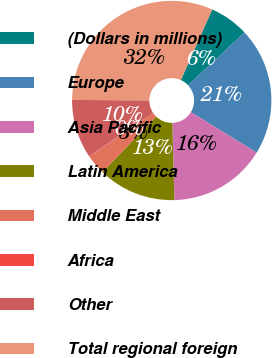Convert chart to OTSL. <chart><loc_0><loc_0><loc_500><loc_500><pie_chart><fcel>(Dollars in millions)<fcel>Europe<fcel>Asia Pacific<fcel>Latin America<fcel>Middle East<fcel>Africa<fcel>Other<fcel>Total regional foreign<nl><fcel>6.38%<fcel>20.72%<fcel>15.82%<fcel>12.68%<fcel>3.23%<fcel>0.08%<fcel>9.53%<fcel>31.57%<nl></chart> 